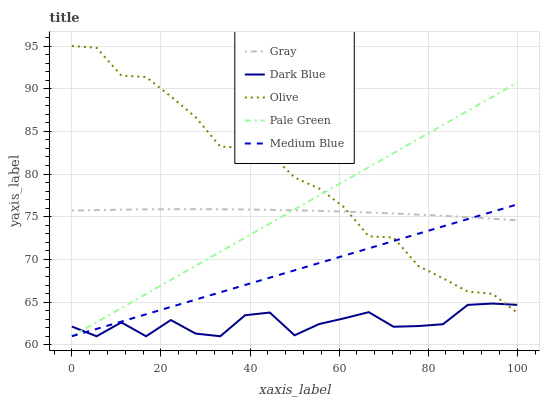Does Gray have the minimum area under the curve?
Answer yes or no. No. Does Gray have the maximum area under the curve?
Answer yes or no. No. Is Gray the smoothest?
Answer yes or no. No. Is Gray the roughest?
Answer yes or no. No. Does Gray have the lowest value?
Answer yes or no. No. Does Gray have the highest value?
Answer yes or no. No. Is Dark Blue less than Gray?
Answer yes or no. Yes. Is Gray greater than Dark Blue?
Answer yes or no. Yes. Does Dark Blue intersect Gray?
Answer yes or no. No. 